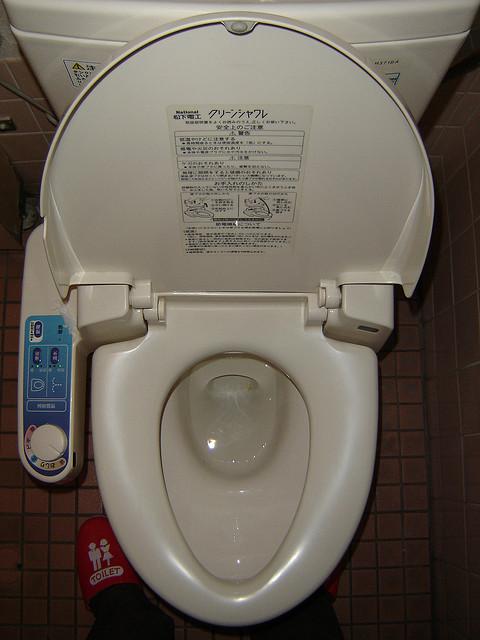Is there water in the toilet?
Be succinct. Yes. What color is this toilet?
Give a very brief answer. White. What is the red thing in front of the toilet?
Write a very short answer. Sign. What room would you find this commode?
Be succinct. Bathroom. Is the lid up or down?
Write a very short answer. Up. 